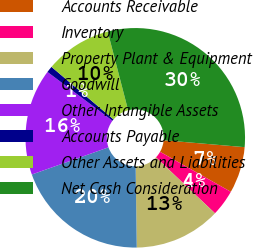Convert chart to OTSL. <chart><loc_0><loc_0><loc_500><loc_500><pie_chart><fcel>Accounts Receivable<fcel>Inventory<fcel>Property Plant & Equipment<fcel>Goodwill<fcel>Other Intangible Assets<fcel>Accounts Payable<fcel>Other Assets and Liabilities<fcel>Net Cash Consideration<nl><fcel>6.83%<fcel>3.88%<fcel>12.72%<fcel>19.79%<fcel>15.67%<fcel>0.94%<fcel>9.78%<fcel>30.4%<nl></chart> 